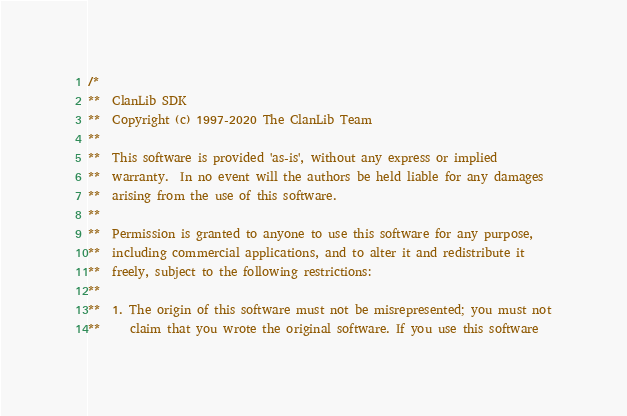Convert code to text. <code><loc_0><loc_0><loc_500><loc_500><_C++_>/*
**  ClanLib SDK
**  Copyright (c) 1997-2020 The ClanLib Team
**
**  This software is provided 'as-is', without any express or implied
**  warranty.  In no event will the authors be held liable for any damages
**  arising from the use of this software.
**
**  Permission is granted to anyone to use this software for any purpose,
**  including commercial applications, and to alter it and redistribute it
**  freely, subject to the following restrictions:
**
**  1. The origin of this software must not be misrepresented; you must not
**     claim that you wrote the original software. If you use this software</code> 